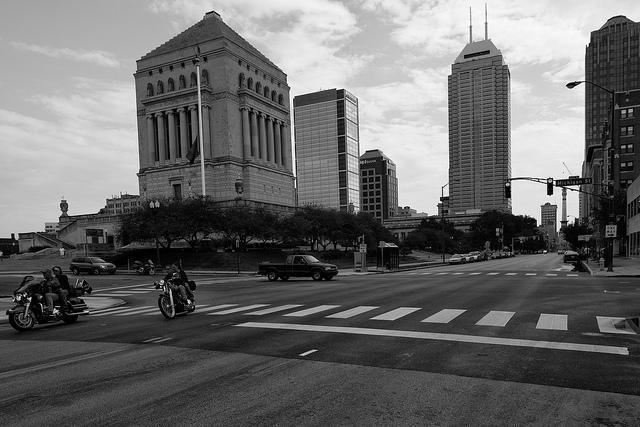How many trucks are on the road?
Give a very brief answer. 1. 